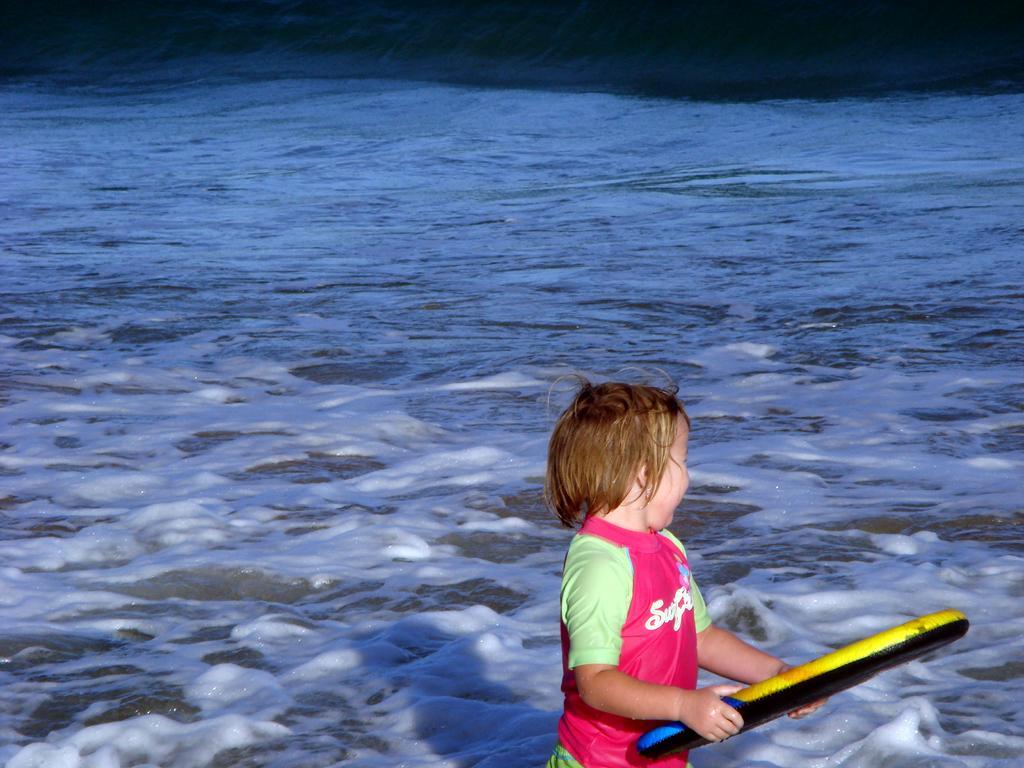How would you summarize this image in a sentence or two? In this image we can see a boy holding an object. In the background of the image there is water. 